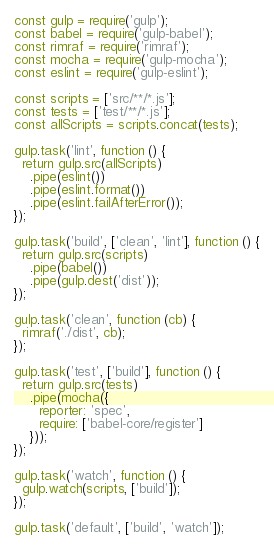Convert code to text. <code><loc_0><loc_0><loc_500><loc_500><_JavaScript_>const gulp = require('gulp');
const babel = require('gulp-babel');
const rimraf = require('rimraf');
const mocha = require('gulp-mocha');
const eslint = require('gulp-eslint');

const scripts = ['src/**/*.js'];
const tests = ['test/**/*.js'];
const allScripts = scripts.concat(tests);

gulp.task('lint', function () {
  return gulp.src(allScripts)
    .pipe(eslint())
    .pipe(eslint.format())
    .pipe(eslint.failAfterError());
});

gulp.task('build', ['clean', 'lint'], function () {
  return gulp.src(scripts)
    .pipe(babel())
    .pipe(gulp.dest('dist'));
});

gulp.task('clean', function (cb) {
  rimraf('./dist', cb);
});

gulp.task('test', ['build'], function () {
  return gulp.src(tests)
    .pipe(mocha({
      reporter: 'spec',
      require: ['babel-core/register']
    }));
});

gulp.task('watch', function () {
  gulp.watch(scripts, ['build']);
});

gulp.task('default', ['build', 'watch']);
</code> 